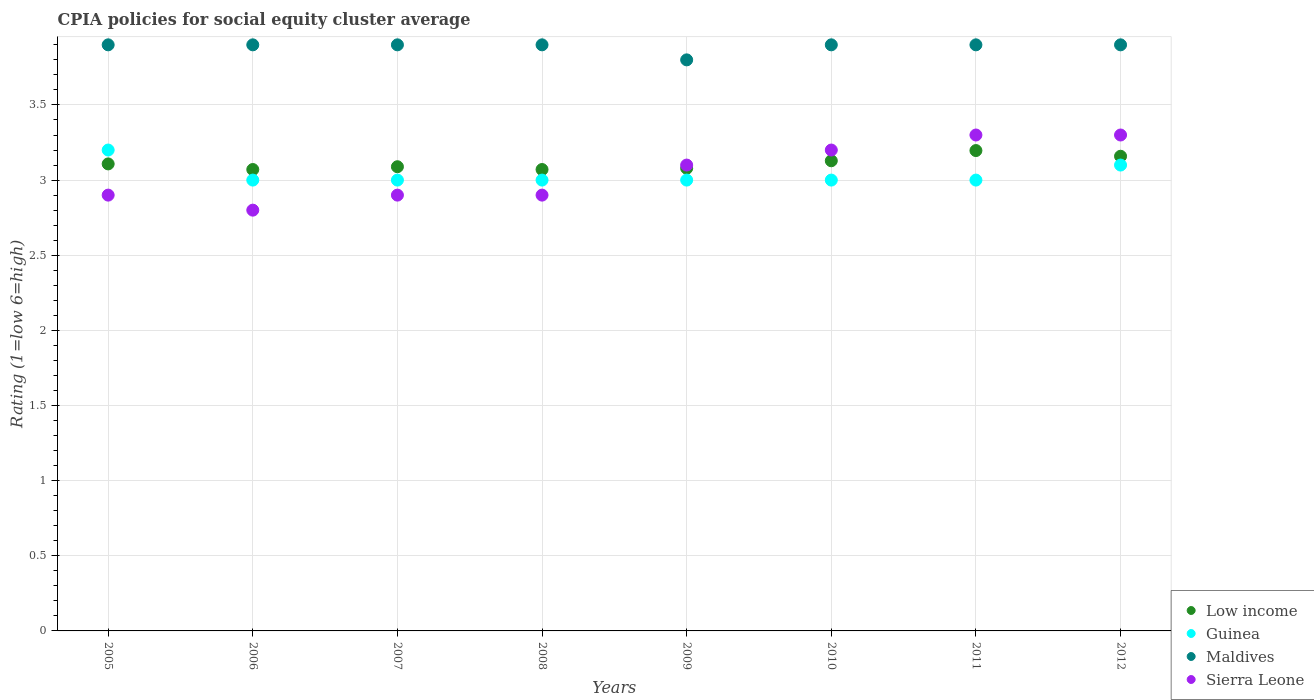What is the CPIA rating in Maldives in 2005?
Offer a terse response. 3.9. Across all years, what is the maximum CPIA rating in Sierra Leone?
Offer a terse response. 3.3. In which year was the CPIA rating in Low income maximum?
Keep it short and to the point. 2011. What is the total CPIA rating in Maldives in the graph?
Provide a succinct answer. 31.1. What is the difference between the CPIA rating in Low income in 2007 and that in 2009?
Ensure brevity in your answer.  0.01. What is the difference between the CPIA rating in Low income in 2005 and the CPIA rating in Maldives in 2008?
Offer a terse response. -0.79. What is the average CPIA rating in Maldives per year?
Your response must be concise. 3.89. In the year 2012, what is the difference between the CPIA rating in Sierra Leone and CPIA rating in Guinea?
Ensure brevity in your answer.  0.2. In how many years, is the CPIA rating in Maldives greater than 3?
Make the answer very short. 8. What is the ratio of the CPIA rating in Low income in 2007 to that in 2010?
Give a very brief answer. 0.99. Is the CPIA rating in Sierra Leone in 2007 less than that in 2009?
Provide a short and direct response. Yes. What is the difference between the highest and the lowest CPIA rating in Guinea?
Make the answer very short. 0.2. In how many years, is the CPIA rating in Guinea greater than the average CPIA rating in Guinea taken over all years?
Provide a short and direct response. 2. Is the sum of the CPIA rating in Guinea in 2007 and 2011 greater than the maximum CPIA rating in Low income across all years?
Make the answer very short. Yes. What is the difference between two consecutive major ticks on the Y-axis?
Offer a terse response. 0.5. Does the graph contain any zero values?
Give a very brief answer. No. How many legend labels are there?
Keep it short and to the point. 4. How are the legend labels stacked?
Provide a succinct answer. Vertical. What is the title of the graph?
Offer a terse response. CPIA policies for social equity cluster average. Does "North America" appear as one of the legend labels in the graph?
Give a very brief answer. No. What is the Rating (1=low 6=high) in Low income in 2005?
Keep it short and to the point. 3.11. What is the Rating (1=low 6=high) in Guinea in 2005?
Provide a succinct answer. 3.2. What is the Rating (1=low 6=high) in Maldives in 2005?
Provide a succinct answer. 3.9. What is the Rating (1=low 6=high) in Low income in 2006?
Offer a very short reply. 3.07. What is the Rating (1=low 6=high) in Guinea in 2006?
Your answer should be very brief. 3. What is the Rating (1=low 6=high) of Maldives in 2006?
Offer a terse response. 3.9. What is the Rating (1=low 6=high) of Sierra Leone in 2006?
Provide a short and direct response. 2.8. What is the Rating (1=low 6=high) of Low income in 2007?
Your answer should be very brief. 3.09. What is the Rating (1=low 6=high) of Low income in 2008?
Give a very brief answer. 3.07. What is the Rating (1=low 6=high) of Guinea in 2008?
Provide a succinct answer. 3. What is the Rating (1=low 6=high) in Low income in 2009?
Your answer should be compact. 3.08. What is the Rating (1=low 6=high) in Guinea in 2009?
Keep it short and to the point. 3. What is the Rating (1=low 6=high) in Maldives in 2009?
Your response must be concise. 3.8. What is the Rating (1=low 6=high) of Sierra Leone in 2009?
Your response must be concise. 3.1. What is the Rating (1=low 6=high) of Low income in 2010?
Provide a short and direct response. 3.13. What is the Rating (1=low 6=high) in Maldives in 2010?
Your response must be concise. 3.9. What is the Rating (1=low 6=high) of Sierra Leone in 2010?
Make the answer very short. 3.2. What is the Rating (1=low 6=high) in Low income in 2011?
Give a very brief answer. 3.2. What is the Rating (1=low 6=high) in Maldives in 2011?
Your answer should be very brief. 3.9. What is the Rating (1=low 6=high) in Low income in 2012?
Your answer should be very brief. 3.16. What is the Rating (1=low 6=high) of Guinea in 2012?
Keep it short and to the point. 3.1. Across all years, what is the maximum Rating (1=low 6=high) in Low income?
Ensure brevity in your answer.  3.2. Across all years, what is the maximum Rating (1=low 6=high) in Maldives?
Keep it short and to the point. 3.9. Across all years, what is the minimum Rating (1=low 6=high) in Low income?
Make the answer very short. 3.07. What is the total Rating (1=low 6=high) in Low income in the graph?
Your response must be concise. 24.9. What is the total Rating (1=low 6=high) in Guinea in the graph?
Make the answer very short. 24.3. What is the total Rating (1=low 6=high) in Maldives in the graph?
Your answer should be very brief. 31.1. What is the total Rating (1=low 6=high) of Sierra Leone in the graph?
Your answer should be compact. 24.4. What is the difference between the Rating (1=low 6=high) in Low income in 2005 and that in 2006?
Keep it short and to the point. 0.04. What is the difference between the Rating (1=low 6=high) of Sierra Leone in 2005 and that in 2006?
Ensure brevity in your answer.  0.1. What is the difference between the Rating (1=low 6=high) of Low income in 2005 and that in 2007?
Offer a terse response. 0.02. What is the difference between the Rating (1=low 6=high) in Low income in 2005 and that in 2008?
Provide a succinct answer. 0.04. What is the difference between the Rating (1=low 6=high) in Maldives in 2005 and that in 2008?
Your response must be concise. 0. What is the difference between the Rating (1=low 6=high) in Low income in 2005 and that in 2009?
Keep it short and to the point. 0.03. What is the difference between the Rating (1=low 6=high) in Guinea in 2005 and that in 2009?
Provide a succinct answer. 0.2. What is the difference between the Rating (1=low 6=high) in Low income in 2005 and that in 2010?
Your answer should be compact. -0.02. What is the difference between the Rating (1=low 6=high) of Maldives in 2005 and that in 2010?
Offer a very short reply. 0. What is the difference between the Rating (1=low 6=high) of Sierra Leone in 2005 and that in 2010?
Provide a succinct answer. -0.3. What is the difference between the Rating (1=low 6=high) of Low income in 2005 and that in 2011?
Offer a very short reply. -0.09. What is the difference between the Rating (1=low 6=high) in Guinea in 2005 and that in 2011?
Your answer should be compact. 0.2. What is the difference between the Rating (1=low 6=high) of Low income in 2005 and that in 2012?
Ensure brevity in your answer.  -0.05. What is the difference between the Rating (1=low 6=high) in Low income in 2006 and that in 2007?
Provide a short and direct response. -0.02. What is the difference between the Rating (1=low 6=high) in Maldives in 2006 and that in 2007?
Your answer should be compact. 0. What is the difference between the Rating (1=low 6=high) of Sierra Leone in 2006 and that in 2007?
Your response must be concise. -0.1. What is the difference between the Rating (1=low 6=high) in Low income in 2006 and that in 2009?
Offer a very short reply. -0.01. What is the difference between the Rating (1=low 6=high) in Guinea in 2006 and that in 2009?
Your answer should be very brief. 0. What is the difference between the Rating (1=low 6=high) of Sierra Leone in 2006 and that in 2009?
Your answer should be very brief. -0.3. What is the difference between the Rating (1=low 6=high) in Low income in 2006 and that in 2010?
Provide a short and direct response. -0.06. What is the difference between the Rating (1=low 6=high) in Maldives in 2006 and that in 2010?
Provide a succinct answer. 0. What is the difference between the Rating (1=low 6=high) of Sierra Leone in 2006 and that in 2010?
Make the answer very short. -0.4. What is the difference between the Rating (1=low 6=high) in Low income in 2006 and that in 2011?
Your answer should be very brief. -0.13. What is the difference between the Rating (1=low 6=high) of Guinea in 2006 and that in 2011?
Ensure brevity in your answer.  0. What is the difference between the Rating (1=low 6=high) of Sierra Leone in 2006 and that in 2011?
Your answer should be very brief. -0.5. What is the difference between the Rating (1=low 6=high) in Low income in 2006 and that in 2012?
Your answer should be compact. -0.09. What is the difference between the Rating (1=low 6=high) in Guinea in 2006 and that in 2012?
Give a very brief answer. -0.1. What is the difference between the Rating (1=low 6=high) in Sierra Leone in 2006 and that in 2012?
Your answer should be compact. -0.5. What is the difference between the Rating (1=low 6=high) in Low income in 2007 and that in 2008?
Your answer should be very brief. 0.02. What is the difference between the Rating (1=low 6=high) in Guinea in 2007 and that in 2008?
Offer a terse response. 0. What is the difference between the Rating (1=low 6=high) of Sierra Leone in 2007 and that in 2008?
Offer a very short reply. 0. What is the difference between the Rating (1=low 6=high) in Low income in 2007 and that in 2009?
Provide a succinct answer. 0.01. What is the difference between the Rating (1=low 6=high) of Guinea in 2007 and that in 2009?
Provide a short and direct response. 0. What is the difference between the Rating (1=low 6=high) of Low income in 2007 and that in 2010?
Your response must be concise. -0.04. What is the difference between the Rating (1=low 6=high) in Guinea in 2007 and that in 2010?
Provide a short and direct response. 0. What is the difference between the Rating (1=low 6=high) in Sierra Leone in 2007 and that in 2010?
Give a very brief answer. -0.3. What is the difference between the Rating (1=low 6=high) of Low income in 2007 and that in 2011?
Offer a terse response. -0.11. What is the difference between the Rating (1=low 6=high) of Sierra Leone in 2007 and that in 2011?
Keep it short and to the point. -0.4. What is the difference between the Rating (1=low 6=high) in Low income in 2007 and that in 2012?
Ensure brevity in your answer.  -0.07. What is the difference between the Rating (1=low 6=high) of Low income in 2008 and that in 2009?
Make the answer very short. -0.01. What is the difference between the Rating (1=low 6=high) in Guinea in 2008 and that in 2009?
Your answer should be very brief. 0. What is the difference between the Rating (1=low 6=high) of Sierra Leone in 2008 and that in 2009?
Make the answer very short. -0.2. What is the difference between the Rating (1=low 6=high) in Low income in 2008 and that in 2010?
Provide a short and direct response. -0.06. What is the difference between the Rating (1=low 6=high) of Guinea in 2008 and that in 2010?
Give a very brief answer. 0. What is the difference between the Rating (1=low 6=high) in Maldives in 2008 and that in 2010?
Make the answer very short. 0. What is the difference between the Rating (1=low 6=high) in Low income in 2008 and that in 2011?
Provide a succinct answer. -0.13. What is the difference between the Rating (1=low 6=high) of Low income in 2008 and that in 2012?
Offer a terse response. -0.09. What is the difference between the Rating (1=low 6=high) in Guinea in 2008 and that in 2012?
Your answer should be very brief. -0.1. What is the difference between the Rating (1=low 6=high) of Sierra Leone in 2008 and that in 2012?
Ensure brevity in your answer.  -0.4. What is the difference between the Rating (1=low 6=high) in Low income in 2009 and that in 2010?
Your answer should be very brief. -0.05. What is the difference between the Rating (1=low 6=high) of Sierra Leone in 2009 and that in 2010?
Your answer should be compact. -0.1. What is the difference between the Rating (1=low 6=high) of Low income in 2009 and that in 2011?
Keep it short and to the point. -0.12. What is the difference between the Rating (1=low 6=high) of Guinea in 2009 and that in 2011?
Offer a very short reply. 0. What is the difference between the Rating (1=low 6=high) in Low income in 2009 and that in 2012?
Provide a short and direct response. -0.08. What is the difference between the Rating (1=low 6=high) of Guinea in 2009 and that in 2012?
Keep it short and to the point. -0.1. What is the difference between the Rating (1=low 6=high) in Maldives in 2009 and that in 2012?
Ensure brevity in your answer.  -0.1. What is the difference between the Rating (1=low 6=high) of Low income in 2010 and that in 2011?
Your response must be concise. -0.07. What is the difference between the Rating (1=low 6=high) in Guinea in 2010 and that in 2011?
Offer a terse response. 0. What is the difference between the Rating (1=low 6=high) of Maldives in 2010 and that in 2011?
Your response must be concise. 0. What is the difference between the Rating (1=low 6=high) in Low income in 2010 and that in 2012?
Your response must be concise. -0.03. What is the difference between the Rating (1=low 6=high) of Guinea in 2010 and that in 2012?
Offer a very short reply. -0.1. What is the difference between the Rating (1=low 6=high) of Sierra Leone in 2010 and that in 2012?
Offer a very short reply. -0.1. What is the difference between the Rating (1=low 6=high) of Low income in 2011 and that in 2012?
Offer a very short reply. 0.04. What is the difference between the Rating (1=low 6=high) of Guinea in 2011 and that in 2012?
Offer a very short reply. -0.1. What is the difference between the Rating (1=low 6=high) in Maldives in 2011 and that in 2012?
Keep it short and to the point. 0. What is the difference between the Rating (1=low 6=high) in Low income in 2005 and the Rating (1=low 6=high) in Guinea in 2006?
Keep it short and to the point. 0.11. What is the difference between the Rating (1=low 6=high) in Low income in 2005 and the Rating (1=low 6=high) in Maldives in 2006?
Keep it short and to the point. -0.79. What is the difference between the Rating (1=low 6=high) in Low income in 2005 and the Rating (1=low 6=high) in Sierra Leone in 2006?
Your answer should be very brief. 0.31. What is the difference between the Rating (1=low 6=high) of Guinea in 2005 and the Rating (1=low 6=high) of Maldives in 2006?
Ensure brevity in your answer.  -0.7. What is the difference between the Rating (1=low 6=high) in Guinea in 2005 and the Rating (1=low 6=high) in Sierra Leone in 2006?
Ensure brevity in your answer.  0.4. What is the difference between the Rating (1=low 6=high) of Low income in 2005 and the Rating (1=low 6=high) of Guinea in 2007?
Give a very brief answer. 0.11. What is the difference between the Rating (1=low 6=high) in Low income in 2005 and the Rating (1=low 6=high) in Maldives in 2007?
Your answer should be very brief. -0.79. What is the difference between the Rating (1=low 6=high) of Low income in 2005 and the Rating (1=low 6=high) of Sierra Leone in 2007?
Offer a very short reply. 0.21. What is the difference between the Rating (1=low 6=high) in Low income in 2005 and the Rating (1=low 6=high) in Guinea in 2008?
Your answer should be very brief. 0.11. What is the difference between the Rating (1=low 6=high) of Low income in 2005 and the Rating (1=low 6=high) of Maldives in 2008?
Keep it short and to the point. -0.79. What is the difference between the Rating (1=low 6=high) in Low income in 2005 and the Rating (1=low 6=high) in Sierra Leone in 2008?
Provide a short and direct response. 0.21. What is the difference between the Rating (1=low 6=high) of Guinea in 2005 and the Rating (1=low 6=high) of Sierra Leone in 2008?
Your answer should be compact. 0.3. What is the difference between the Rating (1=low 6=high) of Maldives in 2005 and the Rating (1=low 6=high) of Sierra Leone in 2008?
Ensure brevity in your answer.  1. What is the difference between the Rating (1=low 6=high) in Low income in 2005 and the Rating (1=low 6=high) in Guinea in 2009?
Make the answer very short. 0.11. What is the difference between the Rating (1=low 6=high) of Low income in 2005 and the Rating (1=low 6=high) of Maldives in 2009?
Offer a very short reply. -0.69. What is the difference between the Rating (1=low 6=high) of Low income in 2005 and the Rating (1=low 6=high) of Sierra Leone in 2009?
Offer a terse response. 0.01. What is the difference between the Rating (1=low 6=high) in Low income in 2005 and the Rating (1=low 6=high) in Guinea in 2010?
Your response must be concise. 0.11. What is the difference between the Rating (1=low 6=high) in Low income in 2005 and the Rating (1=low 6=high) in Maldives in 2010?
Keep it short and to the point. -0.79. What is the difference between the Rating (1=low 6=high) of Low income in 2005 and the Rating (1=low 6=high) of Sierra Leone in 2010?
Offer a terse response. -0.09. What is the difference between the Rating (1=low 6=high) in Guinea in 2005 and the Rating (1=low 6=high) in Sierra Leone in 2010?
Your answer should be compact. 0. What is the difference between the Rating (1=low 6=high) in Maldives in 2005 and the Rating (1=low 6=high) in Sierra Leone in 2010?
Your answer should be compact. 0.7. What is the difference between the Rating (1=low 6=high) of Low income in 2005 and the Rating (1=low 6=high) of Guinea in 2011?
Keep it short and to the point. 0.11. What is the difference between the Rating (1=low 6=high) of Low income in 2005 and the Rating (1=low 6=high) of Maldives in 2011?
Give a very brief answer. -0.79. What is the difference between the Rating (1=low 6=high) of Low income in 2005 and the Rating (1=low 6=high) of Sierra Leone in 2011?
Your response must be concise. -0.19. What is the difference between the Rating (1=low 6=high) of Low income in 2005 and the Rating (1=low 6=high) of Guinea in 2012?
Offer a very short reply. 0.01. What is the difference between the Rating (1=low 6=high) of Low income in 2005 and the Rating (1=low 6=high) of Maldives in 2012?
Your answer should be compact. -0.79. What is the difference between the Rating (1=low 6=high) of Low income in 2005 and the Rating (1=low 6=high) of Sierra Leone in 2012?
Offer a terse response. -0.19. What is the difference between the Rating (1=low 6=high) in Guinea in 2005 and the Rating (1=low 6=high) in Maldives in 2012?
Give a very brief answer. -0.7. What is the difference between the Rating (1=low 6=high) in Low income in 2006 and the Rating (1=low 6=high) in Guinea in 2007?
Your answer should be compact. 0.07. What is the difference between the Rating (1=low 6=high) in Low income in 2006 and the Rating (1=low 6=high) in Maldives in 2007?
Offer a terse response. -0.83. What is the difference between the Rating (1=low 6=high) of Low income in 2006 and the Rating (1=low 6=high) of Sierra Leone in 2007?
Make the answer very short. 0.17. What is the difference between the Rating (1=low 6=high) of Guinea in 2006 and the Rating (1=low 6=high) of Maldives in 2007?
Provide a succinct answer. -0.9. What is the difference between the Rating (1=low 6=high) in Maldives in 2006 and the Rating (1=low 6=high) in Sierra Leone in 2007?
Keep it short and to the point. 1. What is the difference between the Rating (1=low 6=high) in Low income in 2006 and the Rating (1=low 6=high) in Guinea in 2008?
Give a very brief answer. 0.07. What is the difference between the Rating (1=low 6=high) in Low income in 2006 and the Rating (1=low 6=high) in Maldives in 2008?
Offer a terse response. -0.83. What is the difference between the Rating (1=low 6=high) of Low income in 2006 and the Rating (1=low 6=high) of Sierra Leone in 2008?
Your answer should be compact. 0.17. What is the difference between the Rating (1=low 6=high) in Maldives in 2006 and the Rating (1=low 6=high) in Sierra Leone in 2008?
Provide a short and direct response. 1. What is the difference between the Rating (1=low 6=high) of Low income in 2006 and the Rating (1=low 6=high) of Guinea in 2009?
Ensure brevity in your answer.  0.07. What is the difference between the Rating (1=low 6=high) in Low income in 2006 and the Rating (1=low 6=high) in Maldives in 2009?
Give a very brief answer. -0.73. What is the difference between the Rating (1=low 6=high) in Low income in 2006 and the Rating (1=low 6=high) in Sierra Leone in 2009?
Offer a very short reply. -0.03. What is the difference between the Rating (1=low 6=high) of Maldives in 2006 and the Rating (1=low 6=high) of Sierra Leone in 2009?
Your answer should be compact. 0.8. What is the difference between the Rating (1=low 6=high) in Low income in 2006 and the Rating (1=low 6=high) in Guinea in 2010?
Give a very brief answer. 0.07. What is the difference between the Rating (1=low 6=high) of Low income in 2006 and the Rating (1=low 6=high) of Maldives in 2010?
Your response must be concise. -0.83. What is the difference between the Rating (1=low 6=high) of Low income in 2006 and the Rating (1=low 6=high) of Sierra Leone in 2010?
Provide a short and direct response. -0.13. What is the difference between the Rating (1=low 6=high) of Guinea in 2006 and the Rating (1=low 6=high) of Maldives in 2010?
Ensure brevity in your answer.  -0.9. What is the difference between the Rating (1=low 6=high) of Guinea in 2006 and the Rating (1=low 6=high) of Sierra Leone in 2010?
Keep it short and to the point. -0.2. What is the difference between the Rating (1=low 6=high) of Low income in 2006 and the Rating (1=low 6=high) of Guinea in 2011?
Provide a short and direct response. 0.07. What is the difference between the Rating (1=low 6=high) in Low income in 2006 and the Rating (1=low 6=high) in Maldives in 2011?
Your answer should be compact. -0.83. What is the difference between the Rating (1=low 6=high) in Low income in 2006 and the Rating (1=low 6=high) in Sierra Leone in 2011?
Provide a succinct answer. -0.23. What is the difference between the Rating (1=low 6=high) of Guinea in 2006 and the Rating (1=low 6=high) of Maldives in 2011?
Provide a succinct answer. -0.9. What is the difference between the Rating (1=low 6=high) in Maldives in 2006 and the Rating (1=low 6=high) in Sierra Leone in 2011?
Your answer should be compact. 0.6. What is the difference between the Rating (1=low 6=high) in Low income in 2006 and the Rating (1=low 6=high) in Guinea in 2012?
Provide a succinct answer. -0.03. What is the difference between the Rating (1=low 6=high) in Low income in 2006 and the Rating (1=low 6=high) in Maldives in 2012?
Your response must be concise. -0.83. What is the difference between the Rating (1=low 6=high) of Low income in 2006 and the Rating (1=low 6=high) of Sierra Leone in 2012?
Make the answer very short. -0.23. What is the difference between the Rating (1=low 6=high) in Maldives in 2006 and the Rating (1=low 6=high) in Sierra Leone in 2012?
Offer a very short reply. 0.6. What is the difference between the Rating (1=low 6=high) in Low income in 2007 and the Rating (1=low 6=high) in Guinea in 2008?
Provide a succinct answer. 0.09. What is the difference between the Rating (1=low 6=high) of Low income in 2007 and the Rating (1=low 6=high) of Maldives in 2008?
Provide a short and direct response. -0.81. What is the difference between the Rating (1=low 6=high) in Low income in 2007 and the Rating (1=low 6=high) in Sierra Leone in 2008?
Offer a terse response. 0.19. What is the difference between the Rating (1=low 6=high) in Guinea in 2007 and the Rating (1=low 6=high) in Sierra Leone in 2008?
Provide a succinct answer. 0.1. What is the difference between the Rating (1=low 6=high) in Maldives in 2007 and the Rating (1=low 6=high) in Sierra Leone in 2008?
Offer a very short reply. 1. What is the difference between the Rating (1=low 6=high) of Low income in 2007 and the Rating (1=low 6=high) of Guinea in 2009?
Your response must be concise. 0.09. What is the difference between the Rating (1=low 6=high) of Low income in 2007 and the Rating (1=low 6=high) of Maldives in 2009?
Offer a very short reply. -0.71. What is the difference between the Rating (1=low 6=high) of Low income in 2007 and the Rating (1=low 6=high) of Sierra Leone in 2009?
Make the answer very short. -0.01. What is the difference between the Rating (1=low 6=high) in Guinea in 2007 and the Rating (1=low 6=high) in Maldives in 2009?
Give a very brief answer. -0.8. What is the difference between the Rating (1=low 6=high) of Guinea in 2007 and the Rating (1=low 6=high) of Sierra Leone in 2009?
Your answer should be very brief. -0.1. What is the difference between the Rating (1=low 6=high) of Maldives in 2007 and the Rating (1=low 6=high) of Sierra Leone in 2009?
Your answer should be very brief. 0.8. What is the difference between the Rating (1=low 6=high) of Low income in 2007 and the Rating (1=low 6=high) of Guinea in 2010?
Your answer should be very brief. 0.09. What is the difference between the Rating (1=low 6=high) in Low income in 2007 and the Rating (1=low 6=high) in Maldives in 2010?
Ensure brevity in your answer.  -0.81. What is the difference between the Rating (1=low 6=high) in Low income in 2007 and the Rating (1=low 6=high) in Sierra Leone in 2010?
Your response must be concise. -0.11. What is the difference between the Rating (1=low 6=high) in Guinea in 2007 and the Rating (1=low 6=high) in Maldives in 2010?
Provide a short and direct response. -0.9. What is the difference between the Rating (1=low 6=high) in Guinea in 2007 and the Rating (1=low 6=high) in Sierra Leone in 2010?
Give a very brief answer. -0.2. What is the difference between the Rating (1=low 6=high) of Low income in 2007 and the Rating (1=low 6=high) of Guinea in 2011?
Offer a very short reply. 0.09. What is the difference between the Rating (1=low 6=high) of Low income in 2007 and the Rating (1=low 6=high) of Maldives in 2011?
Your answer should be compact. -0.81. What is the difference between the Rating (1=low 6=high) of Low income in 2007 and the Rating (1=low 6=high) of Sierra Leone in 2011?
Provide a succinct answer. -0.21. What is the difference between the Rating (1=low 6=high) of Maldives in 2007 and the Rating (1=low 6=high) of Sierra Leone in 2011?
Give a very brief answer. 0.6. What is the difference between the Rating (1=low 6=high) of Low income in 2007 and the Rating (1=low 6=high) of Guinea in 2012?
Make the answer very short. -0.01. What is the difference between the Rating (1=low 6=high) of Low income in 2007 and the Rating (1=low 6=high) of Maldives in 2012?
Your answer should be very brief. -0.81. What is the difference between the Rating (1=low 6=high) in Low income in 2007 and the Rating (1=low 6=high) in Sierra Leone in 2012?
Offer a terse response. -0.21. What is the difference between the Rating (1=low 6=high) of Maldives in 2007 and the Rating (1=low 6=high) of Sierra Leone in 2012?
Offer a very short reply. 0.6. What is the difference between the Rating (1=low 6=high) in Low income in 2008 and the Rating (1=low 6=high) in Guinea in 2009?
Provide a short and direct response. 0.07. What is the difference between the Rating (1=low 6=high) of Low income in 2008 and the Rating (1=low 6=high) of Maldives in 2009?
Provide a succinct answer. -0.73. What is the difference between the Rating (1=low 6=high) in Low income in 2008 and the Rating (1=low 6=high) in Sierra Leone in 2009?
Offer a terse response. -0.03. What is the difference between the Rating (1=low 6=high) in Maldives in 2008 and the Rating (1=low 6=high) in Sierra Leone in 2009?
Your answer should be compact. 0.8. What is the difference between the Rating (1=low 6=high) in Low income in 2008 and the Rating (1=low 6=high) in Guinea in 2010?
Your answer should be very brief. 0.07. What is the difference between the Rating (1=low 6=high) of Low income in 2008 and the Rating (1=low 6=high) of Maldives in 2010?
Keep it short and to the point. -0.83. What is the difference between the Rating (1=low 6=high) in Low income in 2008 and the Rating (1=low 6=high) in Sierra Leone in 2010?
Your response must be concise. -0.13. What is the difference between the Rating (1=low 6=high) in Low income in 2008 and the Rating (1=low 6=high) in Guinea in 2011?
Offer a very short reply. 0.07. What is the difference between the Rating (1=low 6=high) in Low income in 2008 and the Rating (1=low 6=high) in Maldives in 2011?
Keep it short and to the point. -0.83. What is the difference between the Rating (1=low 6=high) in Low income in 2008 and the Rating (1=low 6=high) in Sierra Leone in 2011?
Give a very brief answer. -0.23. What is the difference between the Rating (1=low 6=high) in Guinea in 2008 and the Rating (1=low 6=high) in Maldives in 2011?
Give a very brief answer. -0.9. What is the difference between the Rating (1=low 6=high) of Low income in 2008 and the Rating (1=low 6=high) of Guinea in 2012?
Offer a very short reply. -0.03. What is the difference between the Rating (1=low 6=high) of Low income in 2008 and the Rating (1=low 6=high) of Maldives in 2012?
Offer a very short reply. -0.83. What is the difference between the Rating (1=low 6=high) of Low income in 2008 and the Rating (1=low 6=high) of Sierra Leone in 2012?
Offer a very short reply. -0.23. What is the difference between the Rating (1=low 6=high) in Maldives in 2008 and the Rating (1=low 6=high) in Sierra Leone in 2012?
Make the answer very short. 0.6. What is the difference between the Rating (1=low 6=high) in Low income in 2009 and the Rating (1=low 6=high) in Guinea in 2010?
Your answer should be compact. 0.08. What is the difference between the Rating (1=low 6=high) in Low income in 2009 and the Rating (1=low 6=high) in Maldives in 2010?
Provide a succinct answer. -0.82. What is the difference between the Rating (1=low 6=high) of Low income in 2009 and the Rating (1=low 6=high) of Sierra Leone in 2010?
Your answer should be very brief. -0.12. What is the difference between the Rating (1=low 6=high) of Guinea in 2009 and the Rating (1=low 6=high) of Sierra Leone in 2010?
Offer a very short reply. -0.2. What is the difference between the Rating (1=low 6=high) of Low income in 2009 and the Rating (1=low 6=high) of Guinea in 2011?
Your answer should be very brief. 0.08. What is the difference between the Rating (1=low 6=high) of Low income in 2009 and the Rating (1=low 6=high) of Maldives in 2011?
Offer a very short reply. -0.82. What is the difference between the Rating (1=low 6=high) in Low income in 2009 and the Rating (1=low 6=high) in Sierra Leone in 2011?
Your answer should be very brief. -0.22. What is the difference between the Rating (1=low 6=high) of Maldives in 2009 and the Rating (1=low 6=high) of Sierra Leone in 2011?
Your response must be concise. 0.5. What is the difference between the Rating (1=low 6=high) of Low income in 2009 and the Rating (1=low 6=high) of Guinea in 2012?
Offer a terse response. -0.02. What is the difference between the Rating (1=low 6=high) in Low income in 2009 and the Rating (1=low 6=high) in Maldives in 2012?
Your answer should be compact. -0.82. What is the difference between the Rating (1=low 6=high) in Low income in 2009 and the Rating (1=low 6=high) in Sierra Leone in 2012?
Offer a very short reply. -0.22. What is the difference between the Rating (1=low 6=high) of Maldives in 2009 and the Rating (1=low 6=high) of Sierra Leone in 2012?
Make the answer very short. 0.5. What is the difference between the Rating (1=low 6=high) in Low income in 2010 and the Rating (1=low 6=high) in Guinea in 2011?
Provide a short and direct response. 0.13. What is the difference between the Rating (1=low 6=high) in Low income in 2010 and the Rating (1=low 6=high) in Maldives in 2011?
Offer a very short reply. -0.77. What is the difference between the Rating (1=low 6=high) in Low income in 2010 and the Rating (1=low 6=high) in Sierra Leone in 2011?
Your answer should be very brief. -0.17. What is the difference between the Rating (1=low 6=high) in Guinea in 2010 and the Rating (1=low 6=high) in Maldives in 2011?
Offer a very short reply. -0.9. What is the difference between the Rating (1=low 6=high) of Maldives in 2010 and the Rating (1=low 6=high) of Sierra Leone in 2011?
Your response must be concise. 0.6. What is the difference between the Rating (1=low 6=high) of Low income in 2010 and the Rating (1=low 6=high) of Guinea in 2012?
Ensure brevity in your answer.  0.03. What is the difference between the Rating (1=low 6=high) of Low income in 2010 and the Rating (1=low 6=high) of Maldives in 2012?
Your response must be concise. -0.77. What is the difference between the Rating (1=low 6=high) in Low income in 2010 and the Rating (1=low 6=high) in Sierra Leone in 2012?
Your answer should be compact. -0.17. What is the difference between the Rating (1=low 6=high) of Maldives in 2010 and the Rating (1=low 6=high) of Sierra Leone in 2012?
Keep it short and to the point. 0.6. What is the difference between the Rating (1=low 6=high) in Low income in 2011 and the Rating (1=low 6=high) in Guinea in 2012?
Offer a very short reply. 0.1. What is the difference between the Rating (1=low 6=high) of Low income in 2011 and the Rating (1=low 6=high) of Maldives in 2012?
Your response must be concise. -0.7. What is the difference between the Rating (1=low 6=high) of Low income in 2011 and the Rating (1=low 6=high) of Sierra Leone in 2012?
Offer a very short reply. -0.1. What is the difference between the Rating (1=low 6=high) in Maldives in 2011 and the Rating (1=low 6=high) in Sierra Leone in 2012?
Offer a very short reply. 0.6. What is the average Rating (1=low 6=high) of Low income per year?
Offer a terse response. 3.11. What is the average Rating (1=low 6=high) of Guinea per year?
Give a very brief answer. 3.04. What is the average Rating (1=low 6=high) of Maldives per year?
Give a very brief answer. 3.89. What is the average Rating (1=low 6=high) in Sierra Leone per year?
Offer a terse response. 3.05. In the year 2005, what is the difference between the Rating (1=low 6=high) of Low income and Rating (1=low 6=high) of Guinea?
Provide a succinct answer. -0.09. In the year 2005, what is the difference between the Rating (1=low 6=high) in Low income and Rating (1=low 6=high) in Maldives?
Offer a very short reply. -0.79. In the year 2005, what is the difference between the Rating (1=low 6=high) of Low income and Rating (1=low 6=high) of Sierra Leone?
Keep it short and to the point. 0.21. In the year 2005, what is the difference between the Rating (1=low 6=high) in Maldives and Rating (1=low 6=high) in Sierra Leone?
Your response must be concise. 1. In the year 2006, what is the difference between the Rating (1=low 6=high) in Low income and Rating (1=low 6=high) in Guinea?
Your answer should be very brief. 0.07. In the year 2006, what is the difference between the Rating (1=low 6=high) in Low income and Rating (1=low 6=high) in Maldives?
Your answer should be compact. -0.83. In the year 2006, what is the difference between the Rating (1=low 6=high) in Low income and Rating (1=low 6=high) in Sierra Leone?
Ensure brevity in your answer.  0.27. In the year 2006, what is the difference between the Rating (1=low 6=high) in Guinea and Rating (1=low 6=high) in Sierra Leone?
Give a very brief answer. 0.2. In the year 2006, what is the difference between the Rating (1=low 6=high) of Maldives and Rating (1=low 6=high) of Sierra Leone?
Provide a short and direct response. 1.1. In the year 2007, what is the difference between the Rating (1=low 6=high) in Low income and Rating (1=low 6=high) in Guinea?
Offer a terse response. 0.09. In the year 2007, what is the difference between the Rating (1=low 6=high) in Low income and Rating (1=low 6=high) in Maldives?
Offer a very short reply. -0.81. In the year 2007, what is the difference between the Rating (1=low 6=high) in Low income and Rating (1=low 6=high) in Sierra Leone?
Your answer should be compact. 0.19. In the year 2007, what is the difference between the Rating (1=low 6=high) in Guinea and Rating (1=low 6=high) in Maldives?
Your response must be concise. -0.9. In the year 2007, what is the difference between the Rating (1=low 6=high) of Guinea and Rating (1=low 6=high) of Sierra Leone?
Your answer should be very brief. 0.1. In the year 2008, what is the difference between the Rating (1=low 6=high) of Low income and Rating (1=low 6=high) of Guinea?
Your response must be concise. 0.07. In the year 2008, what is the difference between the Rating (1=low 6=high) of Low income and Rating (1=low 6=high) of Maldives?
Your answer should be compact. -0.83. In the year 2008, what is the difference between the Rating (1=low 6=high) of Low income and Rating (1=low 6=high) of Sierra Leone?
Offer a terse response. 0.17. In the year 2009, what is the difference between the Rating (1=low 6=high) in Low income and Rating (1=low 6=high) in Guinea?
Your response must be concise. 0.08. In the year 2009, what is the difference between the Rating (1=low 6=high) in Low income and Rating (1=low 6=high) in Maldives?
Offer a terse response. -0.72. In the year 2009, what is the difference between the Rating (1=low 6=high) in Low income and Rating (1=low 6=high) in Sierra Leone?
Ensure brevity in your answer.  -0.02. In the year 2009, what is the difference between the Rating (1=low 6=high) in Guinea and Rating (1=low 6=high) in Maldives?
Keep it short and to the point. -0.8. In the year 2009, what is the difference between the Rating (1=low 6=high) of Guinea and Rating (1=low 6=high) of Sierra Leone?
Your answer should be very brief. -0.1. In the year 2010, what is the difference between the Rating (1=low 6=high) of Low income and Rating (1=low 6=high) of Guinea?
Provide a succinct answer. 0.13. In the year 2010, what is the difference between the Rating (1=low 6=high) in Low income and Rating (1=low 6=high) in Maldives?
Offer a terse response. -0.77. In the year 2010, what is the difference between the Rating (1=low 6=high) in Low income and Rating (1=low 6=high) in Sierra Leone?
Your response must be concise. -0.07. In the year 2010, what is the difference between the Rating (1=low 6=high) of Guinea and Rating (1=low 6=high) of Sierra Leone?
Your response must be concise. -0.2. In the year 2011, what is the difference between the Rating (1=low 6=high) of Low income and Rating (1=low 6=high) of Guinea?
Ensure brevity in your answer.  0.2. In the year 2011, what is the difference between the Rating (1=low 6=high) of Low income and Rating (1=low 6=high) of Maldives?
Your answer should be very brief. -0.7. In the year 2011, what is the difference between the Rating (1=low 6=high) of Low income and Rating (1=low 6=high) of Sierra Leone?
Make the answer very short. -0.1. In the year 2011, what is the difference between the Rating (1=low 6=high) of Guinea and Rating (1=low 6=high) of Sierra Leone?
Keep it short and to the point. -0.3. In the year 2011, what is the difference between the Rating (1=low 6=high) of Maldives and Rating (1=low 6=high) of Sierra Leone?
Ensure brevity in your answer.  0.6. In the year 2012, what is the difference between the Rating (1=low 6=high) of Low income and Rating (1=low 6=high) of Guinea?
Keep it short and to the point. 0.06. In the year 2012, what is the difference between the Rating (1=low 6=high) of Low income and Rating (1=low 6=high) of Maldives?
Your response must be concise. -0.74. In the year 2012, what is the difference between the Rating (1=low 6=high) in Low income and Rating (1=low 6=high) in Sierra Leone?
Provide a short and direct response. -0.14. What is the ratio of the Rating (1=low 6=high) of Low income in 2005 to that in 2006?
Offer a very short reply. 1.01. What is the ratio of the Rating (1=low 6=high) in Guinea in 2005 to that in 2006?
Your answer should be compact. 1.07. What is the ratio of the Rating (1=low 6=high) in Sierra Leone in 2005 to that in 2006?
Offer a terse response. 1.04. What is the ratio of the Rating (1=low 6=high) in Guinea in 2005 to that in 2007?
Offer a very short reply. 1.07. What is the ratio of the Rating (1=low 6=high) of Maldives in 2005 to that in 2007?
Offer a very short reply. 1. What is the ratio of the Rating (1=low 6=high) in Sierra Leone in 2005 to that in 2007?
Provide a succinct answer. 1. What is the ratio of the Rating (1=low 6=high) in Low income in 2005 to that in 2008?
Make the answer very short. 1.01. What is the ratio of the Rating (1=low 6=high) of Guinea in 2005 to that in 2008?
Keep it short and to the point. 1.07. What is the ratio of the Rating (1=low 6=high) in Maldives in 2005 to that in 2008?
Make the answer very short. 1. What is the ratio of the Rating (1=low 6=high) of Sierra Leone in 2005 to that in 2008?
Your answer should be very brief. 1. What is the ratio of the Rating (1=low 6=high) of Low income in 2005 to that in 2009?
Provide a succinct answer. 1.01. What is the ratio of the Rating (1=low 6=high) of Guinea in 2005 to that in 2009?
Provide a succinct answer. 1.07. What is the ratio of the Rating (1=low 6=high) in Maldives in 2005 to that in 2009?
Offer a terse response. 1.03. What is the ratio of the Rating (1=low 6=high) of Sierra Leone in 2005 to that in 2009?
Your answer should be compact. 0.94. What is the ratio of the Rating (1=low 6=high) in Low income in 2005 to that in 2010?
Give a very brief answer. 0.99. What is the ratio of the Rating (1=low 6=high) in Guinea in 2005 to that in 2010?
Offer a terse response. 1.07. What is the ratio of the Rating (1=low 6=high) of Maldives in 2005 to that in 2010?
Offer a very short reply. 1. What is the ratio of the Rating (1=low 6=high) of Sierra Leone in 2005 to that in 2010?
Offer a very short reply. 0.91. What is the ratio of the Rating (1=low 6=high) of Low income in 2005 to that in 2011?
Your answer should be very brief. 0.97. What is the ratio of the Rating (1=low 6=high) of Guinea in 2005 to that in 2011?
Provide a short and direct response. 1.07. What is the ratio of the Rating (1=low 6=high) of Sierra Leone in 2005 to that in 2011?
Provide a succinct answer. 0.88. What is the ratio of the Rating (1=low 6=high) in Low income in 2005 to that in 2012?
Provide a succinct answer. 0.98. What is the ratio of the Rating (1=low 6=high) in Guinea in 2005 to that in 2012?
Ensure brevity in your answer.  1.03. What is the ratio of the Rating (1=low 6=high) of Maldives in 2005 to that in 2012?
Provide a succinct answer. 1. What is the ratio of the Rating (1=low 6=high) in Sierra Leone in 2005 to that in 2012?
Provide a short and direct response. 0.88. What is the ratio of the Rating (1=low 6=high) of Low income in 2006 to that in 2007?
Provide a succinct answer. 0.99. What is the ratio of the Rating (1=low 6=high) in Guinea in 2006 to that in 2007?
Ensure brevity in your answer.  1. What is the ratio of the Rating (1=low 6=high) in Maldives in 2006 to that in 2007?
Your answer should be compact. 1. What is the ratio of the Rating (1=low 6=high) of Sierra Leone in 2006 to that in 2007?
Ensure brevity in your answer.  0.97. What is the ratio of the Rating (1=low 6=high) in Maldives in 2006 to that in 2008?
Your response must be concise. 1. What is the ratio of the Rating (1=low 6=high) in Sierra Leone in 2006 to that in 2008?
Ensure brevity in your answer.  0.97. What is the ratio of the Rating (1=low 6=high) in Low income in 2006 to that in 2009?
Your response must be concise. 1. What is the ratio of the Rating (1=low 6=high) in Guinea in 2006 to that in 2009?
Provide a short and direct response. 1. What is the ratio of the Rating (1=low 6=high) in Maldives in 2006 to that in 2009?
Offer a terse response. 1.03. What is the ratio of the Rating (1=low 6=high) of Sierra Leone in 2006 to that in 2009?
Your answer should be very brief. 0.9. What is the ratio of the Rating (1=low 6=high) of Low income in 2006 to that in 2010?
Provide a short and direct response. 0.98. What is the ratio of the Rating (1=low 6=high) in Low income in 2006 to that in 2011?
Give a very brief answer. 0.96. What is the ratio of the Rating (1=low 6=high) in Guinea in 2006 to that in 2011?
Offer a very short reply. 1. What is the ratio of the Rating (1=low 6=high) of Maldives in 2006 to that in 2011?
Give a very brief answer. 1. What is the ratio of the Rating (1=low 6=high) in Sierra Leone in 2006 to that in 2011?
Your response must be concise. 0.85. What is the ratio of the Rating (1=low 6=high) of Low income in 2006 to that in 2012?
Offer a very short reply. 0.97. What is the ratio of the Rating (1=low 6=high) in Guinea in 2006 to that in 2012?
Make the answer very short. 0.97. What is the ratio of the Rating (1=low 6=high) of Maldives in 2006 to that in 2012?
Offer a very short reply. 1. What is the ratio of the Rating (1=low 6=high) in Sierra Leone in 2006 to that in 2012?
Your answer should be very brief. 0.85. What is the ratio of the Rating (1=low 6=high) of Low income in 2007 to that in 2008?
Make the answer very short. 1.01. What is the ratio of the Rating (1=low 6=high) of Sierra Leone in 2007 to that in 2008?
Give a very brief answer. 1. What is the ratio of the Rating (1=low 6=high) of Maldives in 2007 to that in 2009?
Provide a succinct answer. 1.03. What is the ratio of the Rating (1=low 6=high) of Sierra Leone in 2007 to that in 2009?
Offer a terse response. 0.94. What is the ratio of the Rating (1=low 6=high) in Low income in 2007 to that in 2010?
Offer a terse response. 0.99. What is the ratio of the Rating (1=low 6=high) of Maldives in 2007 to that in 2010?
Make the answer very short. 1. What is the ratio of the Rating (1=low 6=high) of Sierra Leone in 2007 to that in 2010?
Ensure brevity in your answer.  0.91. What is the ratio of the Rating (1=low 6=high) of Low income in 2007 to that in 2011?
Your answer should be very brief. 0.97. What is the ratio of the Rating (1=low 6=high) of Guinea in 2007 to that in 2011?
Give a very brief answer. 1. What is the ratio of the Rating (1=low 6=high) of Maldives in 2007 to that in 2011?
Provide a succinct answer. 1. What is the ratio of the Rating (1=low 6=high) of Sierra Leone in 2007 to that in 2011?
Make the answer very short. 0.88. What is the ratio of the Rating (1=low 6=high) of Low income in 2007 to that in 2012?
Keep it short and to the point. 0.98. What is the ratio of the Rating (1=low 6=high) of Guinea in 2007 to that in 2012?
Your answer should be compact. 0.97. What is the ratio of the Rating (1=low 6=high) of Sierra Leone in 2007 to that in 2012?
Provide a short and direct response. 0.88. What is the ratio of the Rating (1=low 6=high) in Low income in 2008 to that in 2009?
Your answer should be very brief. 1. What is the ratio of the Rating (1=low 6=high) in Maldives in 2008 to that in 2009?
Offer a terse response. 1.03. What is the ratio of the Rating (1=low 6=high) in Sierra Leone in 2008 to that in 2009?
Keep it short and to the point. 0.94. What is the ratio of the Rating (1=low 6=high) in Low income in 2008 to that in 2010?
Make the answer very short. 0.98. What is the ratio of the Rating (1=low 6=high) of Guinea in 2008 to that in 2010?
Give a very brief answer. 1. What is the ratio of the Rating (1=low 6=high) in Sierra Leone in 2008 to that in 2010?
Give a very brief answer. 0.91. What is the ratio of the Rating (1=low 6=high) of Low income in 2008 to that in 2011?
Your answer should be compact. 0.96. What is the ratio of the Rating (1=low 6=high) of Guinea in 2008 to that in 2011?
Keep it short and to the point. 1. What is the ratio of the Rating (1=low 6=high) in Sierra Leone in 2008 to that in 2011?
Offer a very short reply. 0.88. What is the ratio of the Rating (1=low 6=high) of Low income in 2008 to that in 2012?
Give a very brief answer. 0.97. What is the ratio of the Rating (1=low 6=high) in Maldives in 2008 to that in 2012?
Your answer should be very brief. 1. What is the ratio of the Rating (1=low 6=high) of Sierra Leone in 2008 to that in 2012?
Offer a very short reply. 0.88. What is the ratio of the Rating (1=low 6=high) of Maldives in 2009 to that in 2010?
Give a very brief answer. 0.97. What is the ratio of the Rating (1=low 6=high) in Sierra Leone in 2009 to that in 2010?
Your answer should be compact. 0.97. What is the ratio of the Rating (1=low 6=high) in Low income in 2009 to that in 2011?
Your response must be concise. 0.96. What is the ratio of the Rating (1=low 6=high) in Maldives in 2009 to that in 2011?
Offer a terse response. 0.97. What is the ratio of the Rating (1=low 6=high) of Sierra Leone in 2009 to that in 2011?
Give a very brief answer. 0.94. What is the ratio of the Rating (1=low 6=high) in Low income in 2009 to that in 2012?
Provide a short and direct response. 0.97. What is the ratio of the Rating (1=low 6=high) in Maldives in 2009 to that in 2012?
Offer a terse response. 0.97. What is the ratio of the Rating (1=low 6=high) in Sierra Leone in 2009 to that in 2012?
Provide a short and direct response. 0.94. What is the ratio of the Rating (1=low 6=high) in Low income in 2010 to that in 2011?
Your answer should be very brief. 0.98. What is the ratio of the Rating (1=low 6=high) in Maldives in 2010 to that in 2011?
Your response must be concise. 1. What is the ratio of the Rating (1=low 6=high) of Sierra Leone in 2010 to that in 2011?
Your answer should be very brief. 0.97. What is the ratio of the Rating (1=low 6=high) of Low income in 2010 to that in 2012?
Provide a short and direct response. 0.99. What is the ratio of the Rating (1=low 6=high) of Guinea in 2010 to that in 2012?
Your answer should be very brief. 0.97. What is the ratio of the Rating (1=low 6=high) of Maldives in 2010 to that in 2012?
Provide a short and direct response. 1. What is the ratio of the Rating (1=low 6=high) in Sierra Leone in 2010 to that in 2012?
Offer a very short reply. 0.97. What is the ratio of the Rating (1=low 6=high) in Guinea in 2011 to that in 2012?
Your answer should be very brief. 0.97. What is the difference between the highest and the second highest Rating (1=low 6=high) of Low income?
Your response must be concise. 0.04. What is the difference between the highest and the lowest Rating (1=low 6=high) in Low income?
Offer a terse response. 0.13. 